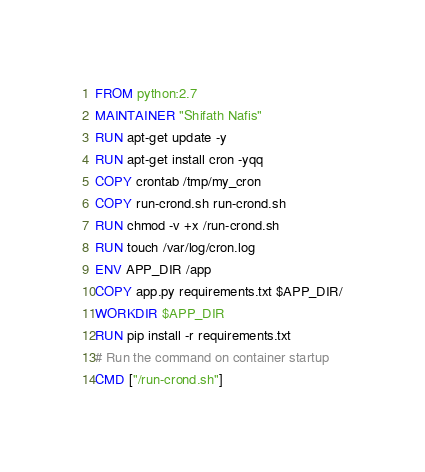Convert code to text. <code><loc_0><loc_0><loc_500><loc_500><_Dockerfile_>FROM python:2.7
MAINTAINER "Shifath Nafis"
RUN apt-get update -y
RUN apt-get install cron -yqq
COPY crontab /tmp/my_cron
COPY run-crond.sh run-crond.sh
RUN chmod -v +x /run-crond.sh
RUN touch /var/log/cron.log
ENV APP_DIR /app
COPY app.py requirements.txt $APP_DIR/
WORKDIR $APP_DIR
RUN pip install -r requirements.txt
# Run the command on container startup
CMD ["/run-crond.sh"]
</code> 